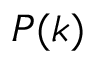<formula> <loc_0><loc_0><loc_500><loc_500>P ( k )</formula> 